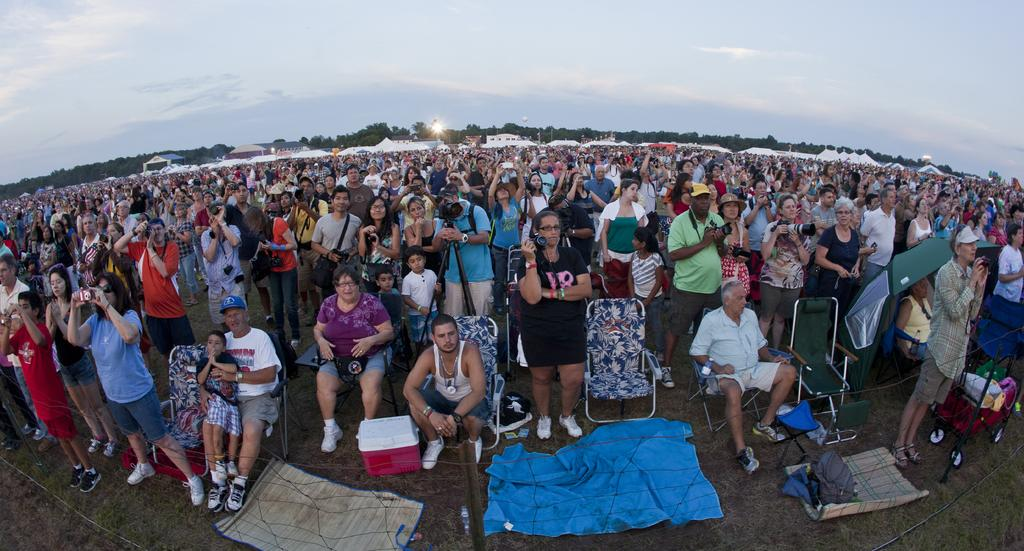What are the people in the image doing? The people in the image are standing and holding cameras. Are there any other people in the image? Yes, there are people seated on chairs in the image. What can be seen in the background of the image? Trees are visible in the image, and the sky is cloudy. What type of chain is being used to support the cork in the image? There is no chain or cork present in the image; it features people standing and holding cameras, seated people, trees, and a cloudy sky. 